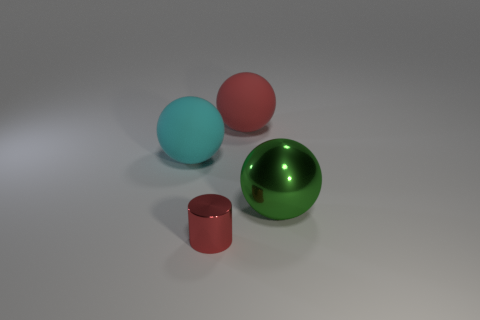Subtract all large rubber balls. How many balls are left? 1 Subtract 2 balls. How many balls are left? 1 Add 4 cylinders. How many objects exist? 8 Subtract all green balls. How many balls are left? 2 Subtract all balls. How many objects are left? 1 Add 4 metal things. How many metal things are left? 6 Add 2 small objects. How many small objects exist? 3 Subtract 1 red cylinders. How many objects are left? 3 Subtract all green balls. Subtract all green cylinders. How many balls are left? 2 Subtract all yellow spheres. How many cyan cylinders are left? 0 